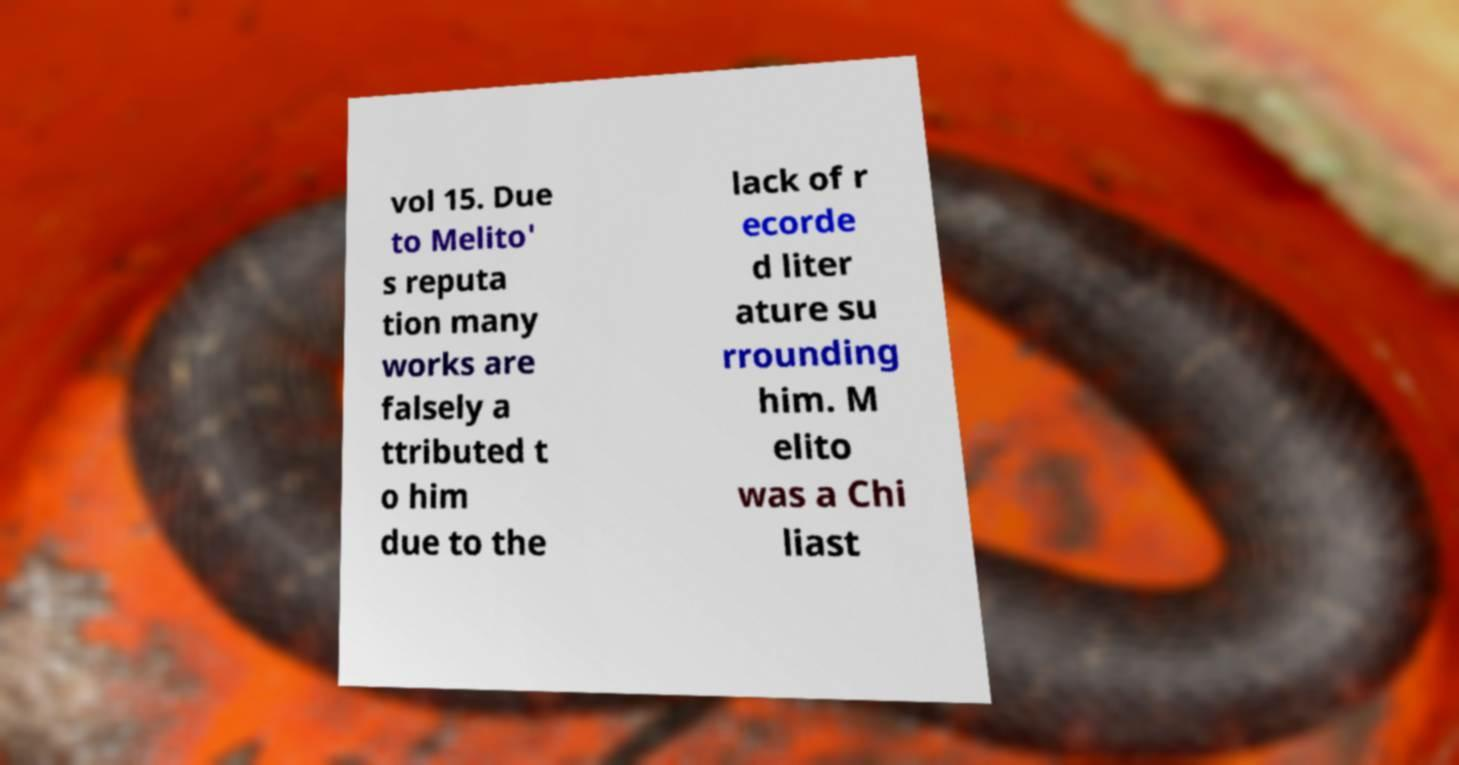Can you read and provide the text displayed in the image?This photo seems to have some interesting text. Can you extract and type it out for me? vol 15. Due to Melito' s reputa tion many works are falsely a ttributed t o him due to the lack of r ecorde d liter ature su rrounding him. M elito was a Chi liast 